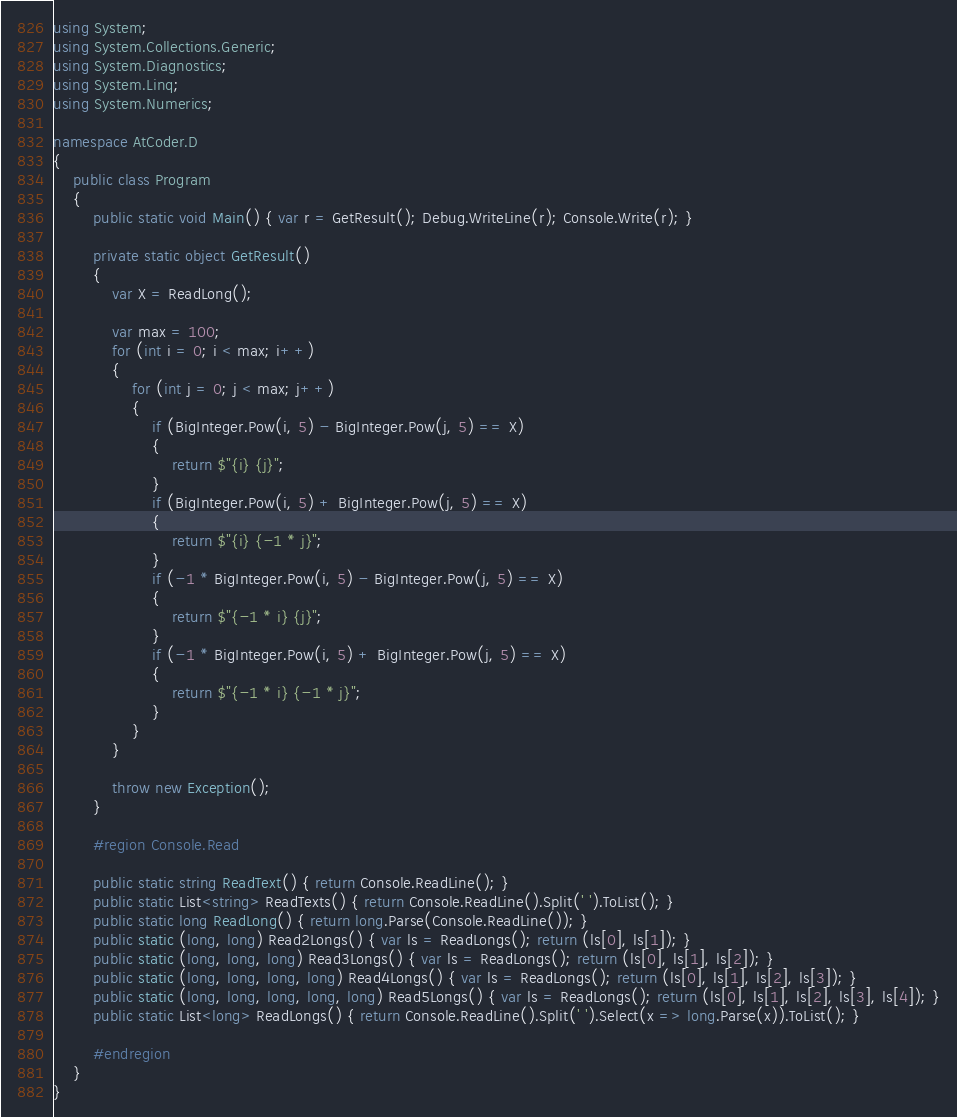<code> <loc_0><loc_0><loc_500><loc_500><_C#_>using System;
using System.Collections.Generic;
using System.Diagnostics;
using System.Linq;
using System.Numerics;

namespace AtCoder.D
{
    public class Program
    {
        public static void Main() { var r = GetResult(); Debug.WriteLine(r); Console.Write(r); }

        private static object GetResult()
        {
            var X = ReadLong();

            var max = 100;
            for (int i = 0; i < max; i++)
            {
                for (int j = 0; j < max; j++)
                {
                    if (BigInteger.Pow(i, 5) - BigInteger.Pow(j, 5) == X)
                    {
                        return $"{i} {j}";
                    }
                    if (BigInteger.Pow(i, 5) + BigInteger.Pow(j, 5) == X)
                    {
                        return $"{i} {-1 * j}";
                    }
                    if (-1 * BigInteger.Pow(i, 5) - BigInteger.Pow(j, 5) == X)
                    {
                        return $"{-1 * i} {j}";
                    }
                    if (-1 * BigInteger.Pow(i, 5) + BigInteger.Pow(j, 5) == X)
                    {
                        return $"{-1 * i} {-1 * j}";
                    }
                }
            }

            throw new Exception();
        }

        #region Console.Read

        public static string ReadText() { return Console.ReadLine(); }
        public static List<string> ReadTexts() { return Console.ReadLine().Split(' ').ToList(); }
        public static long ReadLong() { return long.Parse(Console.ReadLine()); }
        public static (long, long) Read2Longs() { var ls = ReadLongs(); return (ls[0], ls[1]); }
        public static (long, long, long) Read3Longs() { var ls = ReadLongs(); return (ls[0], ls[1], ls[2]); }
        public static (long, long, long, long) Read4Longs() { var ls = ReadLongs(); return (ls[0], ls[1], ls[2], ls[3]); }
        public static (long, long, long, long, long) Read5Longs() { var ls = ReadLongs(); return (ls[0], ls[1], ls[2], ls[3], ls[4]); }
        public static List<long> ReadLongs() { return Console.ReadLine().Split(' ').Select(x => long.Parse(x)).ToList(); }

        #endregion
    }
}
</code> 